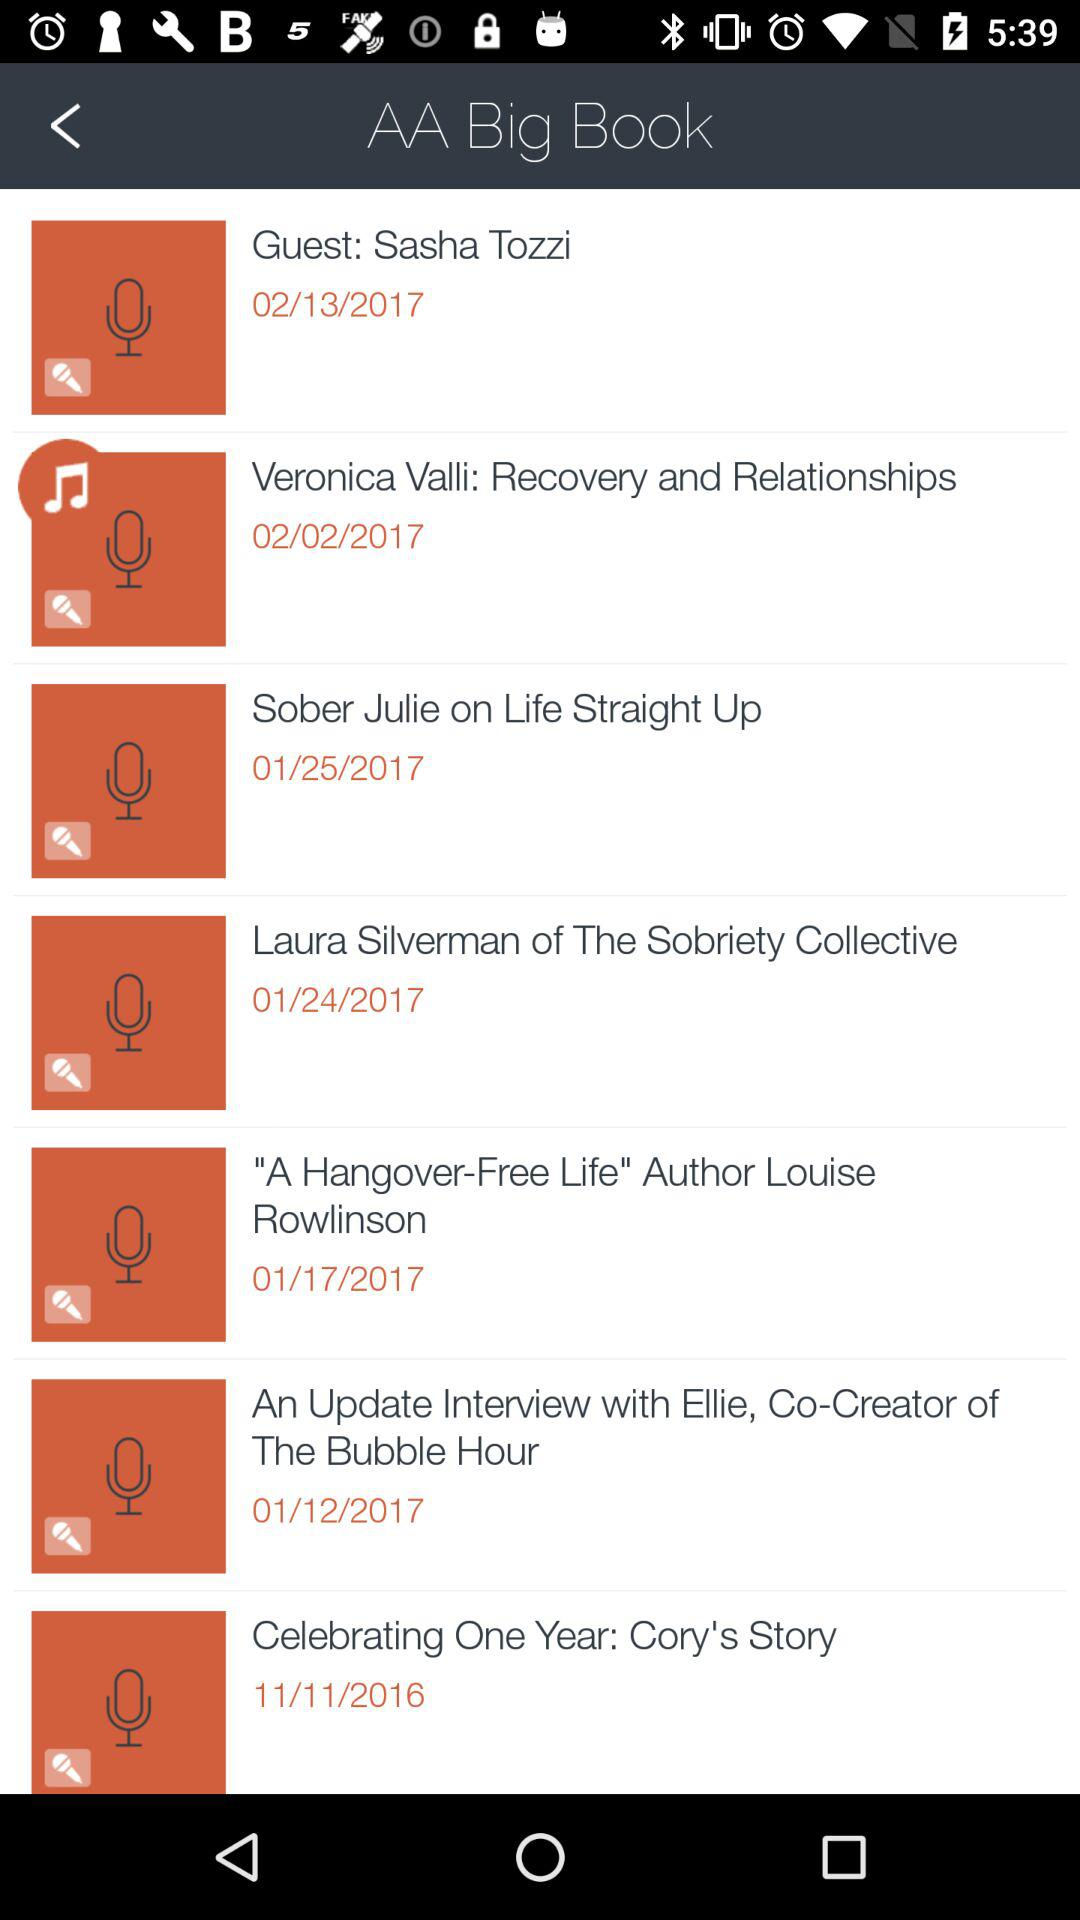How long is the audio file "Veronica Valli: Recovery and Relationships"?
When the provided information is insufficient, respond with <no answer>. <no answer> 